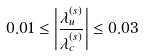<formula> <loc_0><loc_0><loc_500><loc_500>0 . 0 1 \leq \left | \frac { \lambda ^ { ( s ) } _ { u } } { \lambda ^ { ( s ) } _ { c } } \right | \leq 0 . 0 3</formula> 